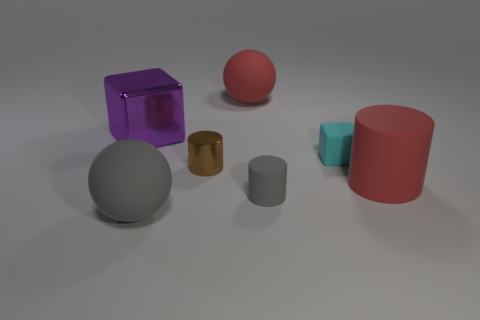How many things are either small objects behind the big red cylinder or big matte things that are behind the matte block?
Your answer should be compact. 3. Are there any tiny matte cylinders that are left of the rubber sphere that is in front of the tiny matte cylinder?
Your answer should be compact. No. There is a cyan object that is the same size as the shiny cylinder; what shape is it?
Make the answer very short. Cube. What number of objects are either things to the left of the gray rubber ball or tiny matte cubes?
Give a very brief answer. 2. What number of other objects are the same material as the large red cylinder?
Offer a very short reply. 4. What shape is the matte thing that is the same color as the small matte cylinder?
Offer a very short reply. Sphere. How big is the gray matte object to the right of the big gray ball?
Your answer should be compact. Small. The cyan thing that is made of the same material as the gray sphere is what shape?
Keep it short and to the point. Cube. Do the small gray object and the red object that is on the left side of the cyan rubber cube have the same material?
Your response must be concise. Yes. Do the big red object that is behind the tiny block and the large purple metal object have the same shape?
Offer a very short reply. No. 